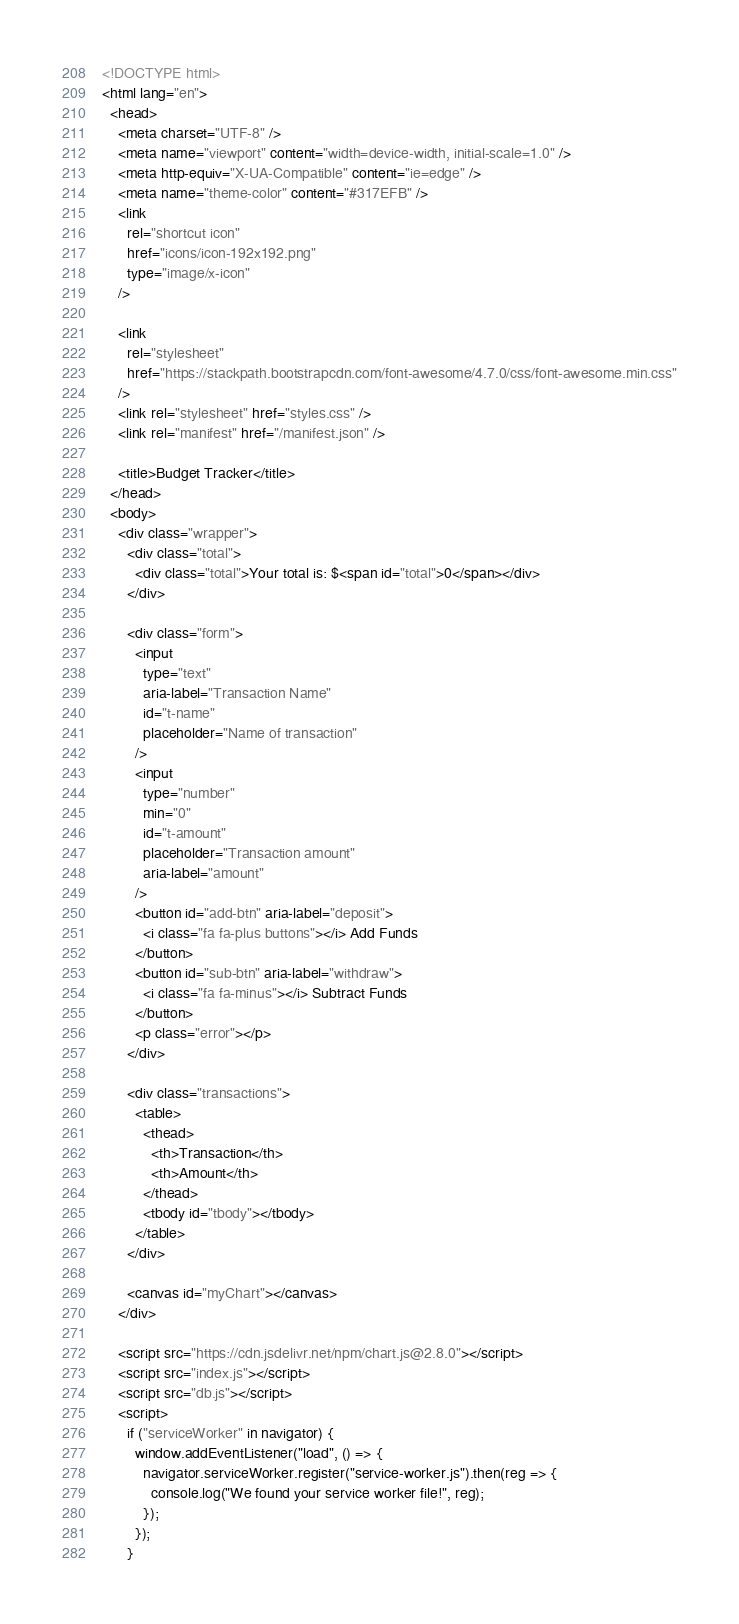<code> <loc_0><loc_0><loc_500><loc_500><_HTML_><!DOCTYPE html>
<html lang="en">
  <head>
    <meta charset="UTF-8" />
    <meta name="viewport" content="width=device-width, initial-scale=1.0" />
    <meta http-equiv="X-UA-Compatible" content="ie=edge" />
    <meta name="theme-color" content="#317EFB" />
    <link
      rel="shortcut icon"
      href="icons/icon-192x192.png"
      type="image/x-icon"
    />

    <link
      rel="stylesheet"
      href="https://stackpath.bootstrapcdn.com/font-awesome/4.7.0/css/font-awesome.min.css"
    />
    <link rel="stylesheet" href="styles.css" />
    <link rel="manifest" href="/manifest.json" />

    <title>Budget Tracker</title>
  </head>
  <body>
    <div class="wrapper">
      <div class="total">
        <div class="total">Your total is: $<span id="total">0</span></div>
      </div>

      <div class="form">
        <input
          type="text"
          aria-label="Transaction Name"
          id="t-name"
          placeholder="Name of transaction"
        />
        <input
          type="number"
          min="0"
          id="t-amount"
          placeholder="Transaction amount"
          aria-label="amount"
        />
        <button id="add-btn" aria-label="deposit">
          <i class="fa fa-plus buttons"></i> Add Funds
        </button>
        <button id="sub-btn" aria-label="withdraw">
          <i class="fa fa-minus"></i> Subtract Funds
        </button>
        <p class="error"></p>
      </div>

      <div class="transactions">
        <table>
          <thead>
            <th>Transaction</th>
            <th>Amount</th>
          </thead>
          <tbody id="tbody"></tbody>
        </table>
      </div>

      <canvas id="myChart"></canvas>
    </div>

    <script src="https://cdn.jsdelivr.net/npm/chart.js@2.8.0"></script>
    <script src="index.js"></script>
    <script src="db.js"></script>
    <script>
      if ("serviceWorker" in navigator) {
        window.addEventListener("load", () => {
          navigator.serviceWorker.register("service-worker.js").then(reg => {
            console.log("We found your service worker file!", reg);
          });
        });
      }</code> 